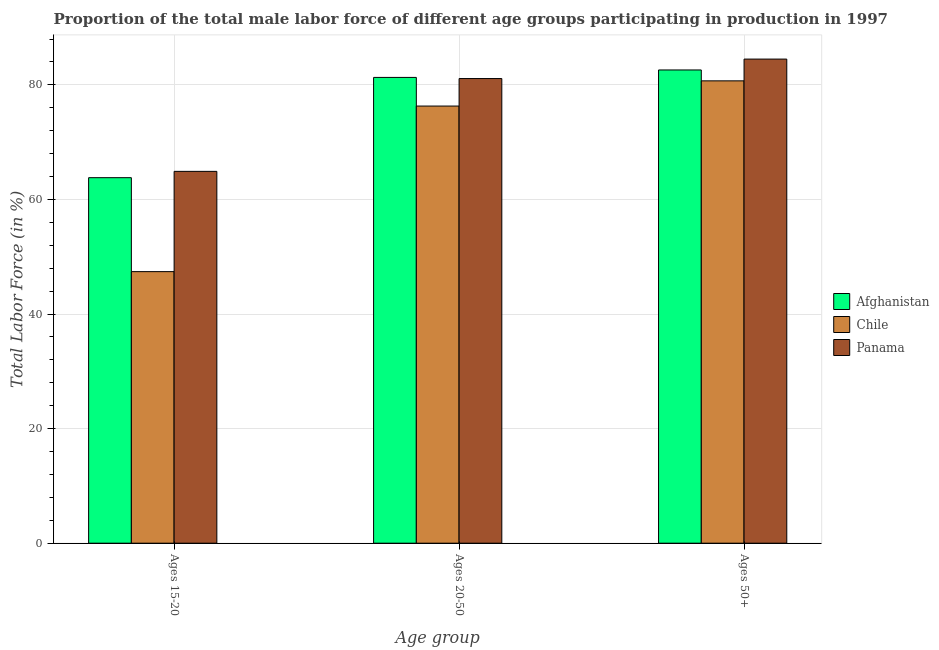How many groups of bars are there?
Your answer should be compact. 3. How many bars are there on the 1st tick from the left?
Provide a succinct answer. 3. How many bars are there on the 3rd tick from the right?
Offer a very short reply. 3. What is the label of the 2nd group of bars from the left?
Your answer should be compact. Ages 20-50. What is the percentage of male labor force within the age group 15-20 in Chile?
Your answer should be very brief. 47.4. Across all countries, what is the maximum percentage of male labor force within the age group 20-50?
Your answer should be compact. 81.3. Across all countries, what is the minimum percentage of male labor force within the age group 20-50?
Provide a short and direct response. 76.3. In which country was the percentage of male labor force within the age group 20-50 maximum?
Keep it short and to the point. Afghanistan. In which country was the percentage of male labor force within the age group 15-20 minimum?
Give a very brief answer. Chile. What is the total percentage of male labor force within the age group 15-20 in the graph?
Ensure brevity in your answer.  176.1. What is the difference between the percentage of male labor force within the age group 20-50 in Afghanistan and that in Panama?
Offer a terse response. 0.2. What is the difference between the percentage of male labor force within the age group 15-20 in Chile and the percentage of male labor force above age 50 in Panama?
Make the answer very short. -37.1. What is the average percentage of male labor force within the age group 20-50 per country?
Provide a succinct answer. 79.57. What is the difference between the percentage of male labor force above age 50 and percentage of male labor force within the age group 20-50 in Panama?
Offer a terse response. 3.4. What is the ratio of the percentage of male labor force above age 50 in Panama to that in Chile?
Keep it short and to the point. 1.05. Is the percentage of male labor force within the age group 15-20 in Panama less than that in Chile?
Give a very brief answer. No. What is the difference between the highest and the second highest percentage of male labor force within the age group 20-50?
Provide a short and direct response. 0.2. What is the difference between the highest and the lowest percentage of male labor force above age 50?
Ensure brevity in your answer.  3.8. In how many countries, is the percentage of male labor force within the age group 15-20 greater than the average percentage of male labor force within the age group 15-20 taken over all countries?
Keep it short and to the point. 2. What does the 2nd bar from the left in Ages 15-20 represents?
Keep it short and to the point. Chile. What does the 3rd bar from the right in Ages 20-50 represents?
Your response must be concise. Afghanistan. Are all the bars in the graph horizontal?
Your answer should be compact. No. What is the difference between two consecutive major ticks on the Y-axis?
Your response must be concise. 20. Does the graph contain any zero values?
Your response must be concise. No. Where does the legend appear in the graph?
Your answer should be very brief. Center right. How many legend labels are there?
Provide a succinct answer. 3. What is the title of the graph?
Your answer should be very brief. Proportion of the total male labor force of different age groups participating in production in 1997. What is the label or title of the X-axis?
Give a very brief answer. Age group. What is the label or title of the Y-axis?
Ensure brevity in your answer.  Total Labor Force (in %). What is the Total Labor Force (in %) of Afghanistan in Ages 15-20?
Give a very brief answer. 63.8. What is the Total Labor Force (in %) of Chile in Ages 15-20?
Offer a terse response. 47.4. What is the Total Labor Force (in %) in Panama in Ages 15-20?
Ensure brevity in your answer.  64.9. What is the Total Labor Force (in %) in Afghanistan in Ages 20-50?
Provide a short and direct response. 81.3. What is the Total Labor Force (in %) of Chile in Ages 20-50?
Make the answer very short. 76.3. What is the Total Labor Force (in %) of Panama in Ages 20-50?
Your answer should be very brief. 81.1. What is the Total Labor Force (in %) of Afghanistan in Ages 50+?
Keep it short and to the point. 82.6. What is the Total Labor Force (in %) in Chile in Ages 50+?
Offer a very short reply. 80.7. What is the Total Labor Force (in %) in Panama in Ages 50+?
Offer a very short reply. 84.5. Across all Age group, what is the maximum Total Labor Force (in %) of Afghanistan?
Your answer should be compact. 82.6. Across all Age group, what is the maximum Total Labor Force (in %) of Chile?
Offer a very short reply. 80.7. Across all Age group, what is the maximum Total Labor Force (in %) in Panama?
Your answer should be very brief. 84.5. Across all Age group, what is the minimum Total Labor Force (in %) in Afghanistan?
Provide a succinct answer. 63.8. Across all Age group, what is the minimum Total Labor Force (in %) in Chile?
Make the answer very short. 47.4. Across all Age group, what is the minimum Total Labor Force (in %) in Panama?
Offer a very short reply. 64.9. What is the total Total Labor Force (in %) of Afghanistan in the graph?
Offer a terse response. 227.7. What is the total Total Labor Force (in %) in Chile in the graph?
Offer a very short reply. 204.4. What is the total Total Labor Force (in %) of Panama in the graph?
Make the answer very short. 230.5. What is the difference between the Total Labor Force (in %) of Afghanistan in Ages 15-20 and that in Ages 20-50?
Make the answer very short. -17.5. What is the difference between the Total Labor Force (in %) of Chile in Ages 15-20 and that in Ages 20-50?
Offer a very short reply. -28.9. What is the difference between the Total Labor Force (in %) in Panama in Ages 15-20 and that in Ages 20-50?
Your answer should be very brief. -16.2. What is the difference between the Total Labor Force (in %) of Afghanistan in Ages 15-20 and that in Ages 50+?
Ensure brevity in your answer.  -18.8. What is the difference between the Total Labor Force (in %) in Chile in Ages 15-20 and that in Ages 50+?
Keep it short and to the point. -33.3. What is the difference between the Total Labor Force (in %) of Panama in Ages 15-20 and that in Ages 50+?
Ensure brevity in your answer.  -19.6. What is the difference between the Total Labor Force (in %) in Afghanistan in Ages 15-20 and the Total Labor Force (in %) in Chile in Ages 20-50?
Provide a short and direct response. -12.5. What is the difference between the Total Labor Force (in %) of Afghanistan in Ages 15-20 and the Total Labor Force (in %) of Panama in Ages 20-50?
Offer a terse response. -17.3. What is the difference between the Total Labor Force (in %) in Chile in Ages 15-20 and the Total Labor Force (in %) in Panama in Ages 20-50?
Provide a short and direct response. -33.7. What is the difference between the Total Labor Force (in %) in Afghanistan in Ages 15-20 and the Total Labor Force (in %) in Chile in Ages 50+?
Your answer should be very brief. -16.9. What is the difference between the Total Labor Force (in %) in Afghanistan in Ages 15-20 and the Total Labor Force (in %) in Panama in Ages 50+?
Offer a terse response. -20.7. What is the difference between the Total Labor Force (in %) in Chile in Ages 15-20 and the Total Labor Force (in %) in Panama in Ages 50+?
Offer a very short reply. -37.1. What is the difference between the Total Labor Force (in %) of Afghanistan in Ages 20-50 and the Total Labor Force (in %) of Chile in Ages 50+?
Offer a very short reply. 0.6. What is the difference between the Total Labor Force (in %) of Afghanistan in Ages 20-50 and the Total Labor Force (in %) of Panama in Ages 50+?
Ensure brevity in your answer.  -3.2. What is the difference between the Total Labor Force (in %) of Chile in Ages 20-50 and the Total Labor Force (in %) of Panama in Ages 50+?
Give a very brief answer. -8.2. What is the average Total Labor Force (in %) of Afghanistan per Age group?
Offer a very short reply. 75.9. What is the average Total Labor Force (in %) in Chile per Age group?
Give a very brief answer. 68.13. What is the average Total Labor Force (in %) in Panama per Age group?
Your answer should be very brief. 76.83. What is the difference between the Total Labor Force (in %) in Chile and Total Labor Force (in %) in Panama in Ages 15-20?
Your answer should be compact. -17.5. What is the difference between the Total Labor Force (in %) of Afghanistan and Total Labor Force (in %) of Chile in Ages 20-50?
Your answer should be compact. 5. What is the difference between the Total Labor Force (in %) in Afghanistan and Total Labor Force (in %) in Panama in Ages 20-50?
Your answer should be compact. 0.2. What is the difference between the Total Labor Force (in %) in Chile and Total Labor Force (in %) in Panama in Ages 20-50?
Your response must be concise. -4.8. What is the ratio of the Total Labor Force (in %) of Afghanistan in Ages 15-20 to that in Ages 20-50?
Offer a terse response. 0.78. What is the ratio of the Total Labor Force (in %) of Chile in Ages 15-20 to that in Ages 20-50?
Your response must be concise. 0.62. What is the ratio of the Total Labor Force (in %) in Panama in Ages 15-20 to that in Ages 20-50?
Your answer should be very brief. 0.8. What is the ratio of the Total Labor Force (in %) of Afghanistan in Ages 15-20 to that in Ages 50+?
Your answer should be compact. 0.77. What is the ratio of the Total Labor Force (in %) of Chile in Ages 15-20 to that in Ages 50+?
Your response must be concise. 0.59. What is the ratio of the Total Labor Force (in %) in Panama in Ages 15-20 to that in Ages 50+?
Offer a very short reply. 0.77. What is the ratio of the Total Labor Force (in %) of Afghanistan in Ages 20-50 to that in Ages 50+?
Your answer should be compact. 0.98. What is the ratio of the Total Labor Force (in %) in Chile in Ages 20-50 to that in Ages 50+?
Provide a short and direct response. 0.95. What is the ratio of the Total Labor Force (in %) in Panama in Ages 20-50 to that in Ages 50+?
Your answer should be very brief. 0.96. What is the difference between the highest and the second highest Total Labor Force (in %) in Afghanistan?
Your response must be concise. 1.3. What is the difference between the highest and the second highest Total Labor Force (in %) of Panama?
Your response must be concise. 3.4. What is the difference between the highest and the lowest Total Labor Force (in %) of Afghanistan?
Keep it short and to the point. 18.8. What is the difference between the highest and the lowest Total Labor Force (in %) in Chile?
Your answer should be compact. 33.3. What is the difference between the highest and the lowest Total Labor Force (in %) in Panama?
Keep it short and to the point. 19.6. 